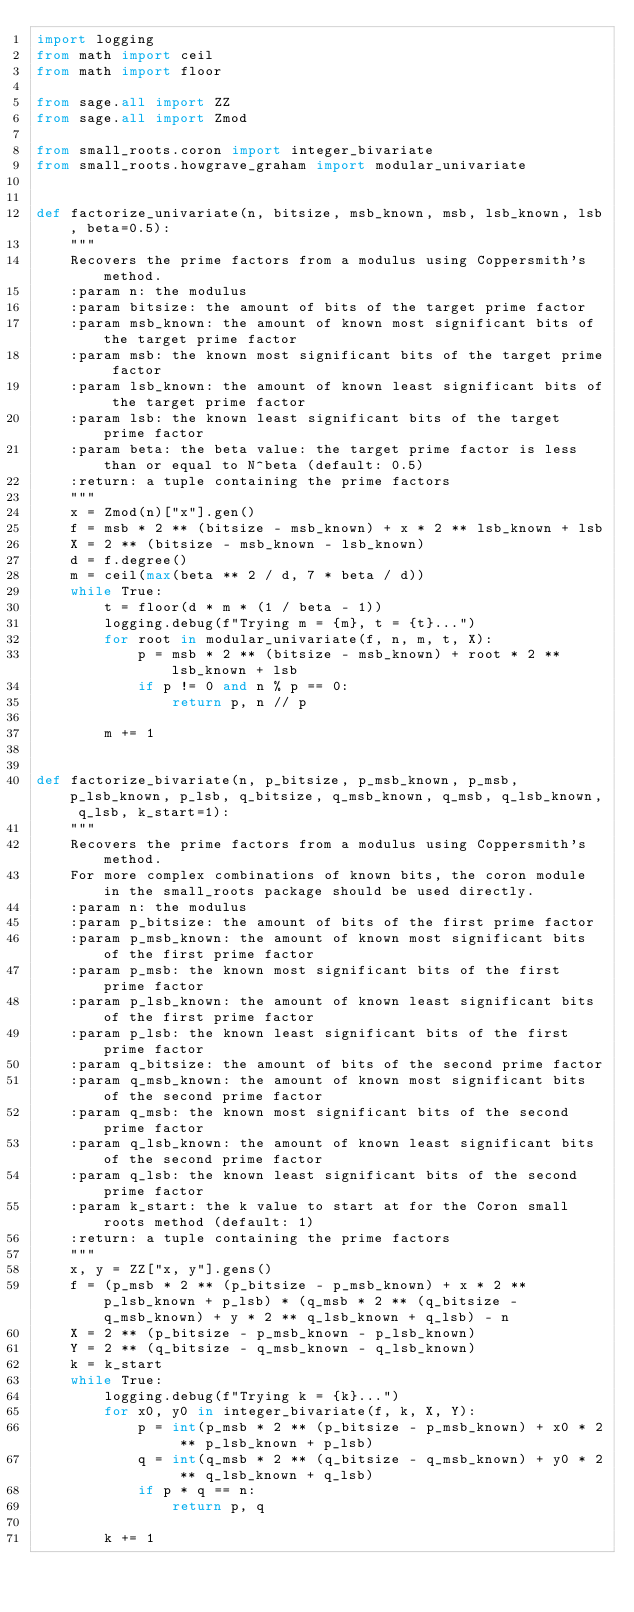Convert code to text. <code><loc_0><loc_0><loc_500><loc_500><_Python_>import logging
from math import ceil
from math import floor

from sage.all import ZZ
from sage.all import Zmod

from small_roots.coron import integer_bivariate
from small_roots.howgrave_graham import modular_univariate


def factorize_univariate(n, bitsize, msb_known, msb, lsb_known, lsb, beta=0.5):
    """
    Recovers the prime factors from a modulus using Coppersmith's method.
    :param n: the modulus
    :param bitsize: the amount of bits of the target prime factor
    :param msb_known: the amount of known most significant bits of the target prime factor
    :param msb: the known most significant bits of the target prime factor
    :param lsb_known: the amount of known least significant bits of the target prime factor
    :param lsb: the known least significant bits of the target prime factor
    :param beta: the beta value: the target prime factor is less than or equal to N^beta (default: 0.5)
    :return: a tuple containing the prime factors
    """
    x = Zmod(n)["x"].gen()
    f = msb * 2 ** (bitsize - msb_known) + x * 2 ** lsb_known + lsb
    X = 2 ** (bitsize - msb_known - lsb_known)
    d = f.degree()
    m = ceil(max(beta ** 2 / d, 7 * beta / d))
    while True:
        t = floor(d * m * (1 / beta - 1))
        logging.debug(f"Trying m = {m}, t = {t}...")
        for root in modular_univariate(f, n, m, t, X):
            p = msb * 2 ** (bitsize - msb_known) + root * 2 ** lsb_known + lsb
            if p != 0 and n % p == 0:
                return p, n // p

        m += 1


def factorize_bivariate(n, p_bitsize, p_msb_known, p_msb, p_lsb_known, p_lsb, q_bitsize, q_msb_known, q_msb, q_lsb_known, q_lsb, k_start=1):
    """
    Recovers the prime factors from a modulus using Coppersmith's method.
    For more complex combinations of known bits, the coron module in the small_roots package should be used directly.
    :param n: the modulus
    :param p_bitsize: the amount of bits of the first prime factor
    :param p_msb_known: the amount of known most significant bits of the first prime factor
    :param p_msb: the known most significant bits of the first prime factor
    :param p_lsb_known: the amount of known least significant bits of the first prime factor
    :param p_lsb: the known least significant bits of the first prime factor
    :param q_bitsize: the amount of bits of the second prime factor
    :param q_msb_known: the amount of known most significant bits of the second prime factor
    :param q_msb: the known most significant bits of the second prime factor
    :param q_lsb_known: the amount of known least significant bits of the second prime factor
    :param q_lsb: the known least significant bits of the second prime factor
    :param k_start: the k value to start at for the Coron small roots method (default: 1)
    :return: a tuple containing the prime factors
    """
    x, y = ZZ["x, y"].gens()
    f = (p_msb * 2 ** (p_bitsize - p_msb_known) + x * 2 ** p_lsb_known + p_lsb) * (q_msb * 2 ** (q_bitsize - q_msb_known) + y * 2 ** q_lsb_known + q_lsb) - n
    X = 2 ** (p_bitsize - p_msb_known - p_lsb_known)
    Y = 2 ** (q_bitsize - q_msb_known - q_lsb_known)
    k = k_start
    while True:
        logging.debug(f"Trying k = {k}...")
        for x0, y0 in integer_bivariate(f, k, X, Y):
            p = int(p_msb * 2 ** (p_bitsize - p_msb_known) + x0 * 2 ** p_lsb_known + p_lsb)
            q = int(q_msb * 2 ** (q_bitsize - q_msb_known) + y0 * 2 ** q_lsb_known + q_lsb)
            if p * q == n:
                return p, q

        k += 1
</code> 